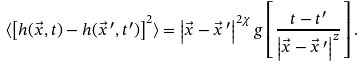Convert formula to latex. <formula><loc_0><loc_0><loc_500><loc_500>\langle \left [ h ( \vec { x } , t ) - h ( \vec { x } \, ^ { \prime } , t ^ { \prime } ) \right ] ^ { 2 } \rangle = \left | \vec { x } - \vec { x } \, ^ { \prime } \right | ^ { 2 \chi } g \left [ \frac { t - t ^ { \prime } } { \left | \vec { x } - \vec { x } \, ^ { \prime } \right | ^ { z } } \right ] .</formula> 